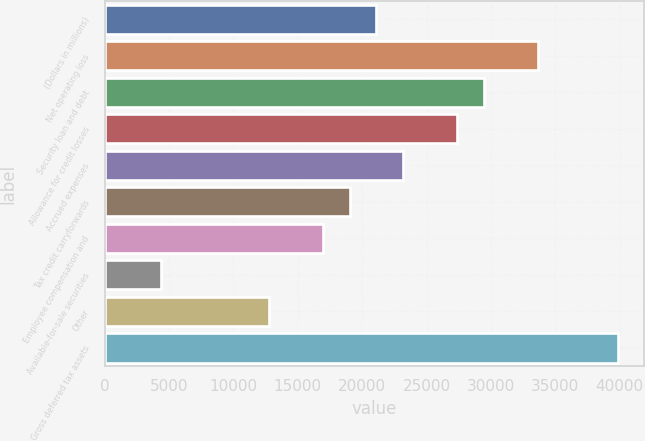<chart> <loc_0><loc_0><loc_500><loc_500><bar_chart><fcel>(Dollars in millions)<fcel>Net operating loss<fcel>Security loan and debt<fcel>Allowance for credit losses<fcel>Accrued expenses<fcel>Tax credit carryforwards<fcel>Employee compensation and<fcel>Available-for-sale securities<fcel>Other<fcel>Gross deferred tax assets<nl><fcel>21106<fcel>33633.4<fcel>29457.6<fcel>27369.7<fcel>23193.9<fcel>19018.1<fcel>16930.2<fcel>4402.8<fcel>12754.4<fcel>39897.1<nl></chart> 